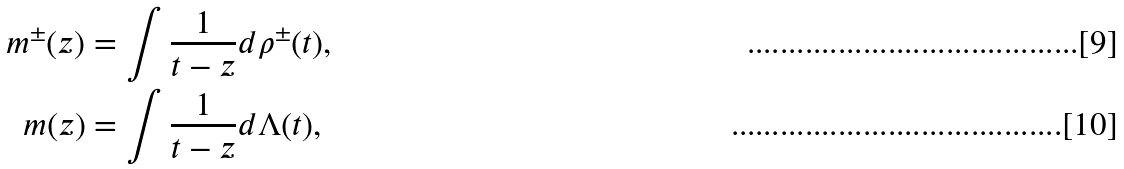<formula> <loc_0><loc_0><loc_500><loc_500>m ^ { \pm } ( z ) & = \int \frac { 1 } { t - z } d \rho ^ { \pm } ( t ) , \\ m ( z ) & = \int \frac { 1 } { t - z } d \Lambda ( t ) ,</formula> 